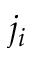<formula> <loc_0><loc_0><loc_500><loc_500>j _ { i }</formula> 